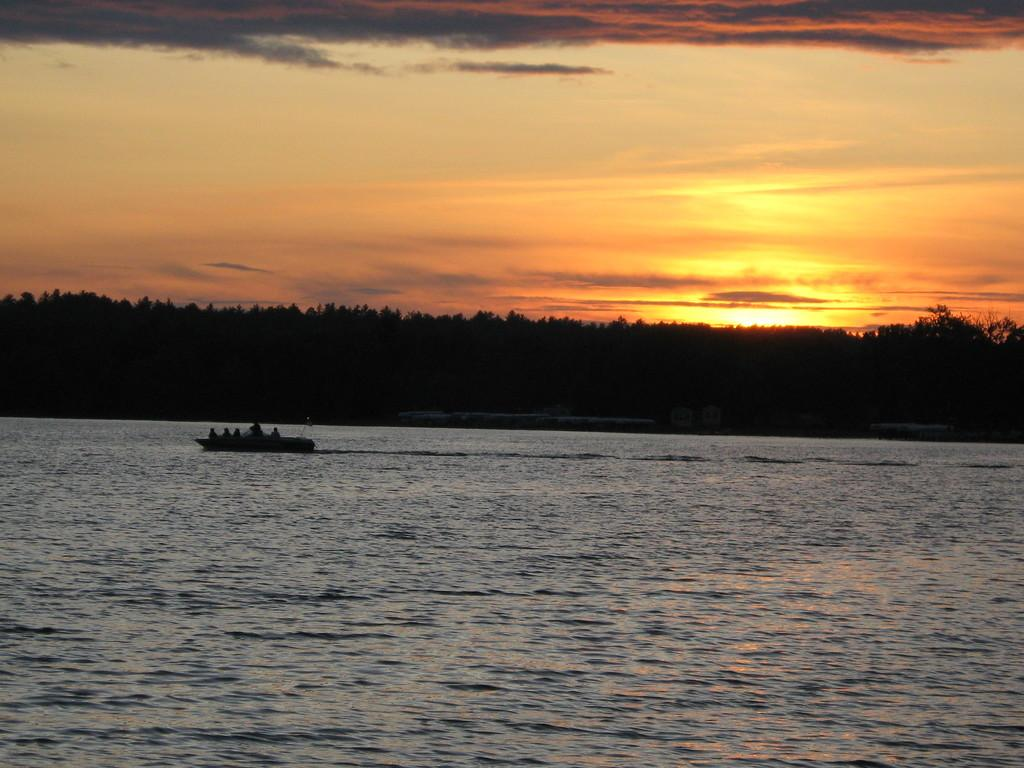What is the main subject of the image? The main subject of the image is a ship. Are there any people on the ship? Yes, there are people on the ship. What is the ship doing in the image? The ship is sailing on the water. What can be seen in the background of the image? Trees and the sky are visible in the image. What type of payment is being made by the lawyer in the image? There is no lawyer or payment present in the image; it features a ship sailing on the water with people on board. Can you tell me which eye of the person on the ship is visible in the image? There is no person's eye visible in the image; only the ship, people, trees, and sky are present. 